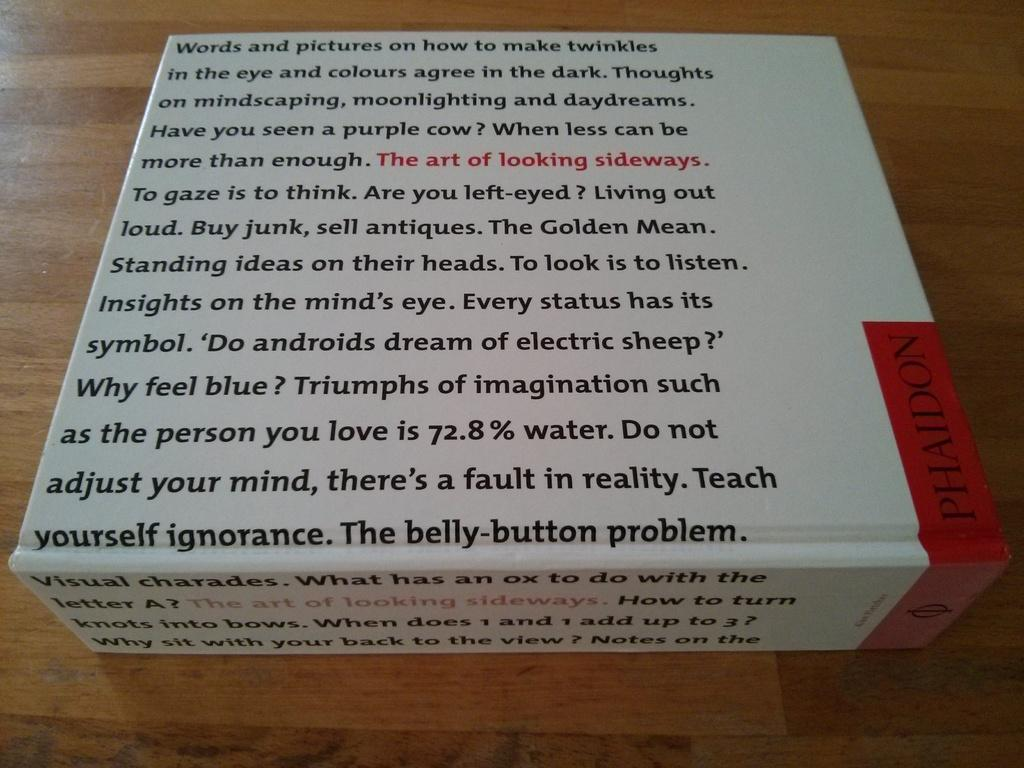<image>
Write a terse but informative summary of the picture. A thick book says something about a belly-button problem on the cover. 